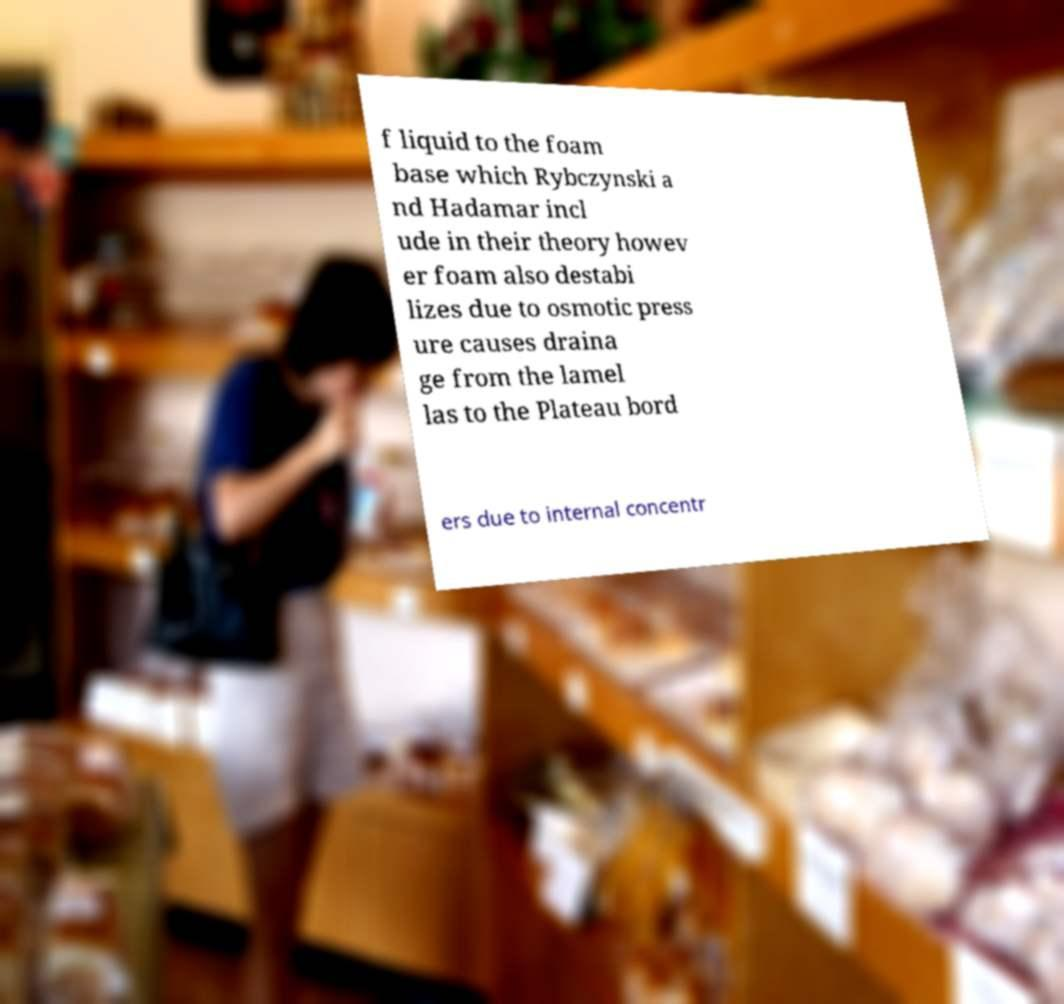Can you read and provide the text displayed in the image?This photo seems to have some interesting text. Can you extract and type it out for me? f liquid to the foam base which Rybczynski a nd Hadamar incl ude in their theory howev er foam also destabi lizes due to osmotic press ure causes draina ge from the lamel las to the Plateau bord ers due to internal concentr 